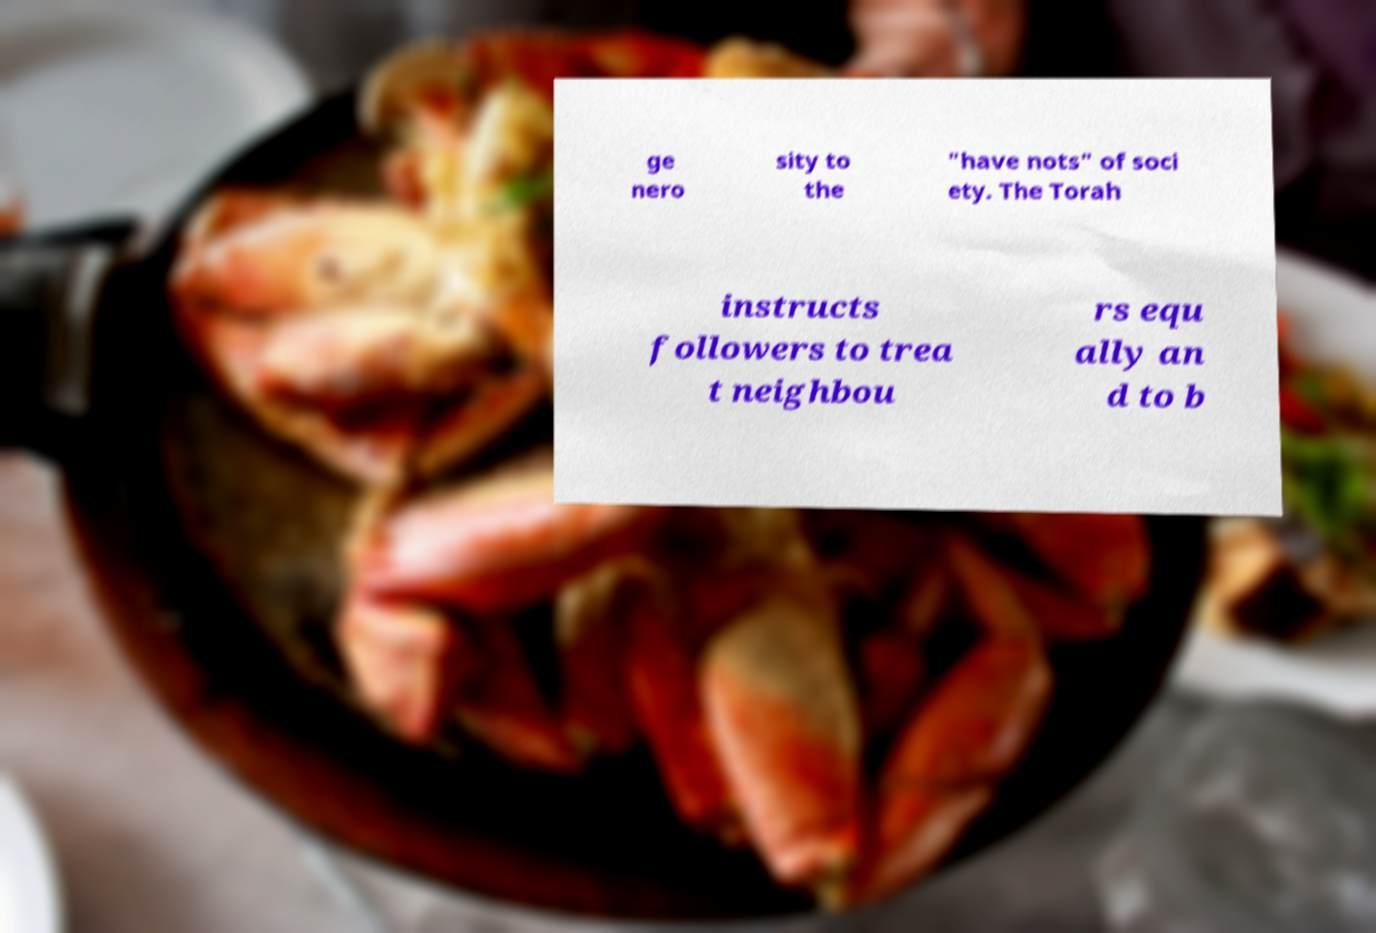Please identify and transcribe the text found in this image. ge nero sity to the "have nots" of soci ety. The Torah instructs followers to trea t neighbou rs equ ally an d to b 